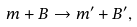<formula> <loc_0><loc_0><loc_500><loc_500>m + B \to m ^ { \prime } + B ^ { \prime } ,</formula> 